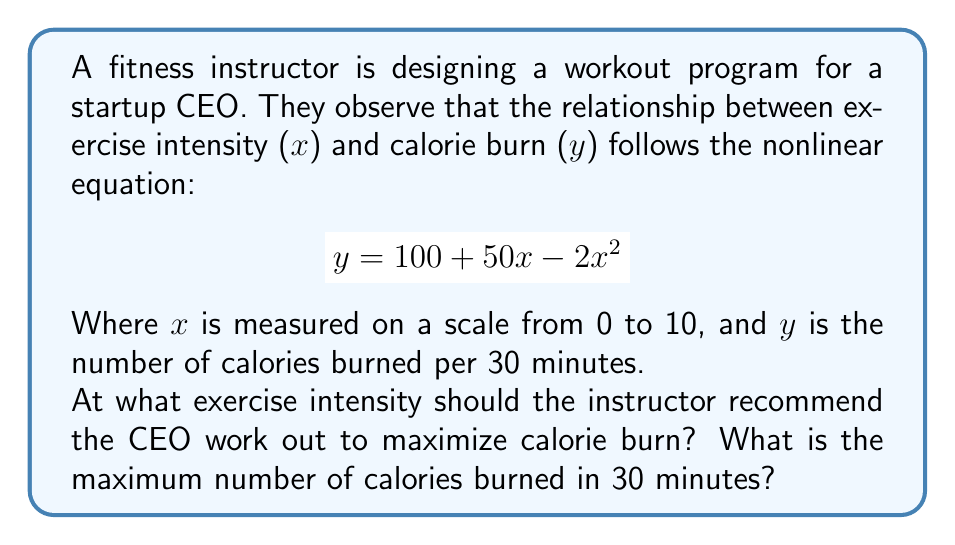What is the answer to this math problem? To find the maximum calorie burn, we need to find the vertex of the quadratic function. This can be done using the following steps:

1) The general form of a quadratic function is $f(x) = ax^2 + bx + c$. In this case:
   $a = -2$, $b = 50$, and $c = 100$

2) The x-coordinate of the vertex is given by the formula $x = -\frac{b}{2a}$:

   $$x = -\frac{50}{2(-2)} = -\frac{50}{-4} = \frac{50}{4} = 12.5$$

3) However, since the scale is from 0 to 10, we need to restrict our answer to this range. The maximum within this range will occur at $x = 10$.

4) To find the maximum number of calories burned, we substitute $x = 10$ into the original equation:

   $$y = 100 + 50(10) - 2(10)^2$$
   $$y = 100 + 500 - 200$$
   $$y = 400$$

Therefore, the maximum calorie burn occurs at an intensity of 10, burning 400 calories in 30 minutes.
Answer: Intensity: 10; Maximum calories: 400 